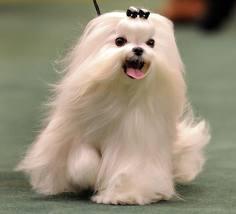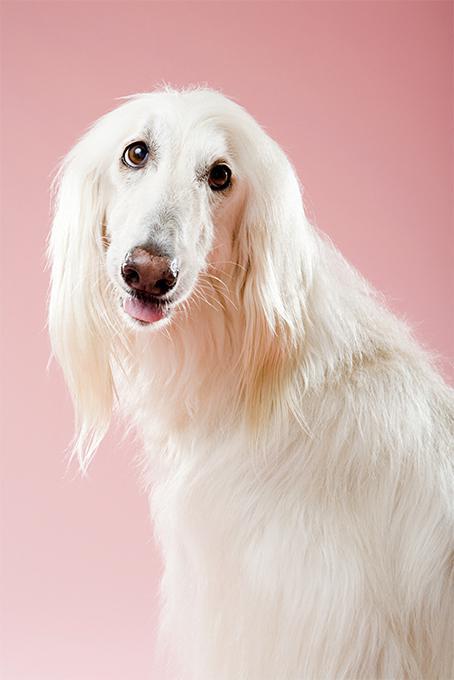The first image is the image on the left, the second image is the image on the right. Examine the images to the left and right. Is the description "The dog in the image on the right has a white coat." accurate? Answer yes or no. Yes. 